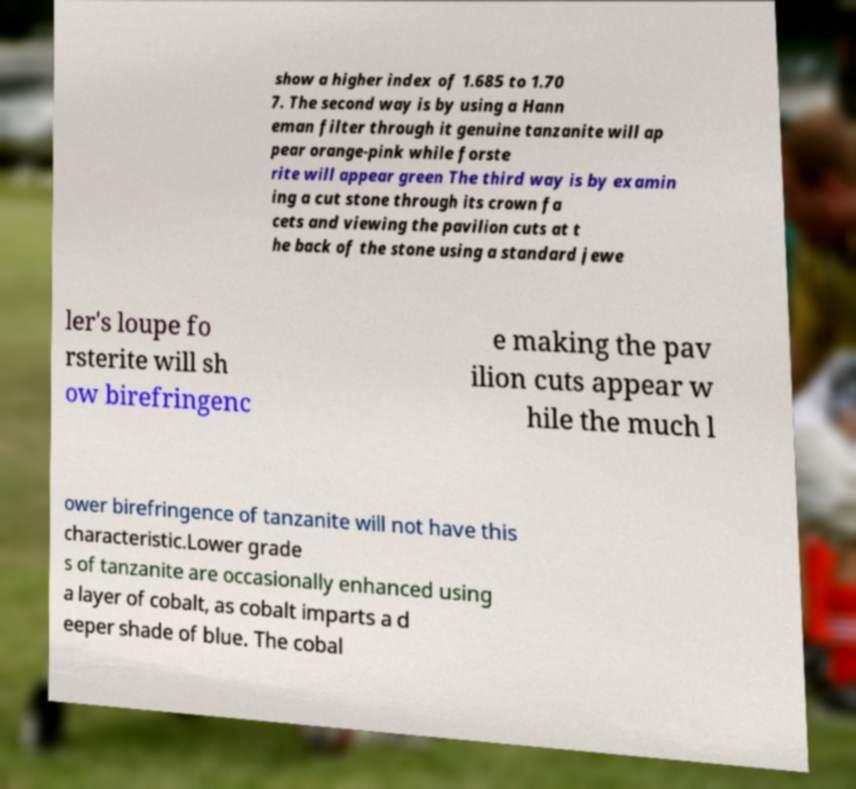There's text embedded in this image that I need extracted. Can you transcribe it verbatim? show a higher index of 1.685 to 1.70 7. The second way is by using a Hann eman filter through it genuine tanzanite will ap pear orange-pink while forste rite will appear green The third way is by examin ing a cut stone through its crown fa cets and viewing the pavilion cuts at t he back of the stone using a standard jewe ler's loupe fo rsterite will sh ow birefringenc e making the pav ilion cuts appear w hile the much l ower birefringence of tanzanite will not have this characteristic.Lower grade s of tanzanite are occasionally enhanced using a layer of cobalt, as cobalt imparts a d eeper shade of blue. The cobal 